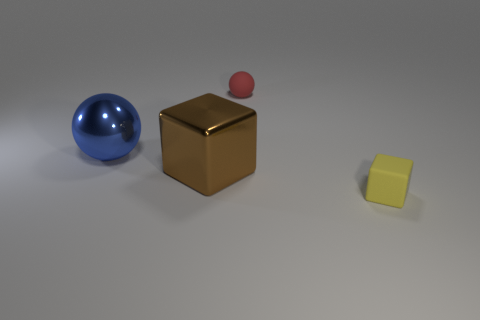What number of other objects are there of the same material as the big blue object?
Give a very brief answer. 1. Is there a red ball?
Offer a terse response. Yes. Is the block on the left side of the small rubber block made of the same material as the tiny sphere?
Offer a terse response. No. There is a yellow thing that is the same shape as the big brown object; what material is it?
Give a very brief answer. Rubber. Are there fewer blue cylinders than rubber blocks?
Provide a succinct answer. Yes. There is a rubber thing that is in front of the blue object; is it the same color as the small rubber ball?
Your answer should be very brief. No. What is the color of the other thing that is the same material as the tiny red thing?
Give a very brief answer. Yellow. Does the blue shiny thing have the same size as the yellow matte object?
Offer a very short reply. No. What is the material of the red object?
Your answer should be very brief. Rubber. There is a thing that is the same size as the red matte ball; what is its material?
Offer a very short reply. Rubber. 